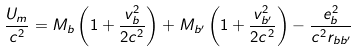Convert formula to latex. <formula><loc_0><loc_0><loc_500><loc_500>\frac { U _ { m } } { c ^ { 2 } } = M _ { b } \left ( 1 + \frac { v _ { b } ^ { 2 } } { 2 c ^ { 2 } } \right ) + M _ { b ^ { \prime } } \left ( 1 + \frac { v _ { b ^ { \prime } } ^ { 2 } } { 2 c ^ { 2 } } \right ) - \frac { e _ { b } ^ { 2 } } { c ^ { 2 } r _ { b b ^ { \prime } } }</formula> 